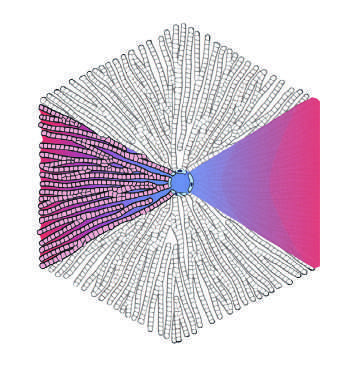re the portal tracts at the periphery?
Answer the question using a single word or phrase. Yes 